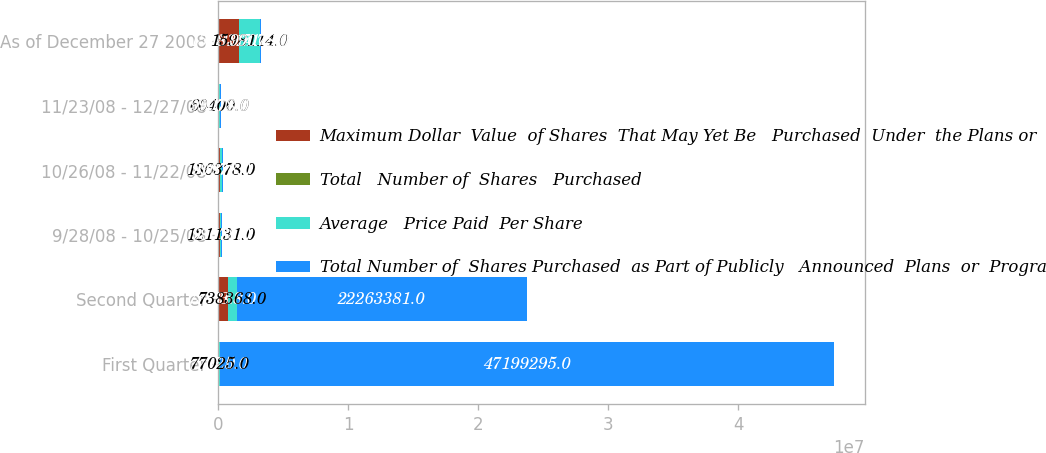Convert chart. <chart><loc_0><loc_0><loc_500><loc_500><stacked_bar_chart><ecel><fcel>First Quarter<fcel>Second Quarter<fcel>9/28/08 - 10/25/08<fcel>10/26/08 - 11/22/08<fcel>11/23/08 - 12/27/08<fcel>As of December 27 2008<nl><fcel>Maximum Dollar  Value  of Shares  That May Yet Be   Purchased  Under  the Plans or   Programs<fcel>77025<fcel>738368<fcel>121131<fcel>136378<fcel>60400<fcel>1.59811e+06<nl><fcel>Total   Number of  Shares   Purchased<fcel>37<fcel>33.8<fcel>36.12<fcel>35.35<fcel>35.93<fcel>33.71<nl><fcel>Average   Price Paid  Per Share<fcel>77025<fcel>738368<fcel>121131<fcel>136378<fcel>60400<fcel>1.59811e+06<nl><fcel>Total Number of  Shares Purchased  as Part of Publicly   Announced  Plans  or  Programs<fcel>4.71993e+07<fcel>2.22634e+07<fcel>99078<fcel>99078<fcel>99078<fcel>99078<nl></chart> 